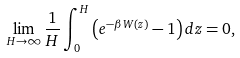<formula> <loc_0><loc_0><loc_500><loc_500>\lim _ { H \rightarrow \infty } \frac { 1 } { H } \int _ { 0 } ^ { H } \left ( e ^ { - \beta W ( z ) } - 1 \right ) d z = 0 ,</formula> 